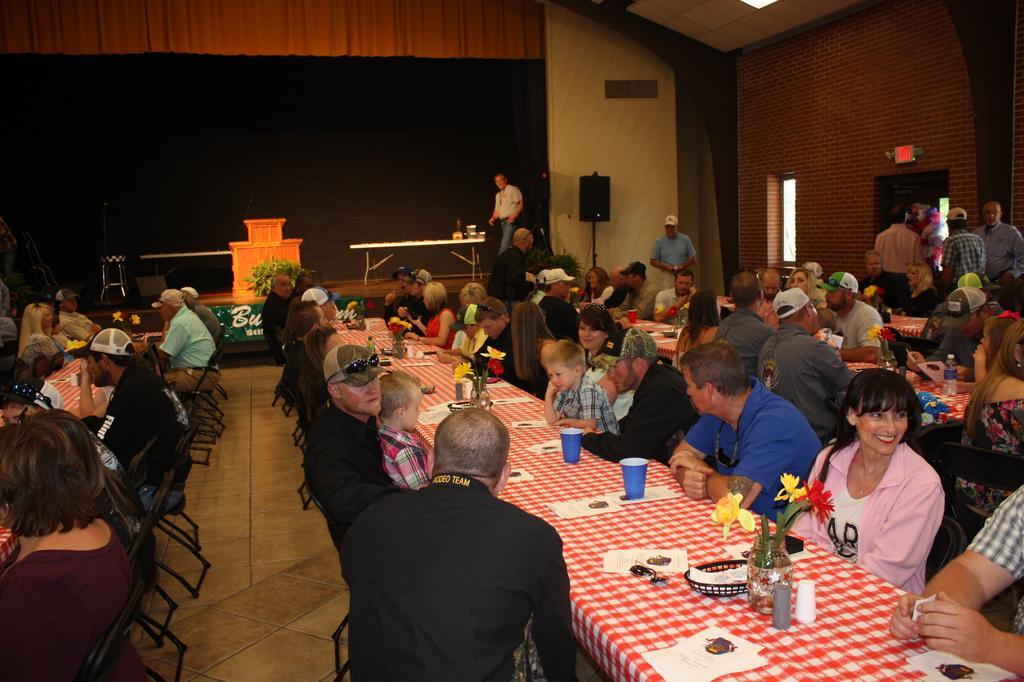In one or two sentences, can you explain what this image depicts? There are group of people sitting in chairs and there is a table in front of them and the table consists of a cup,paper and a flower vase and the background is black in color. 